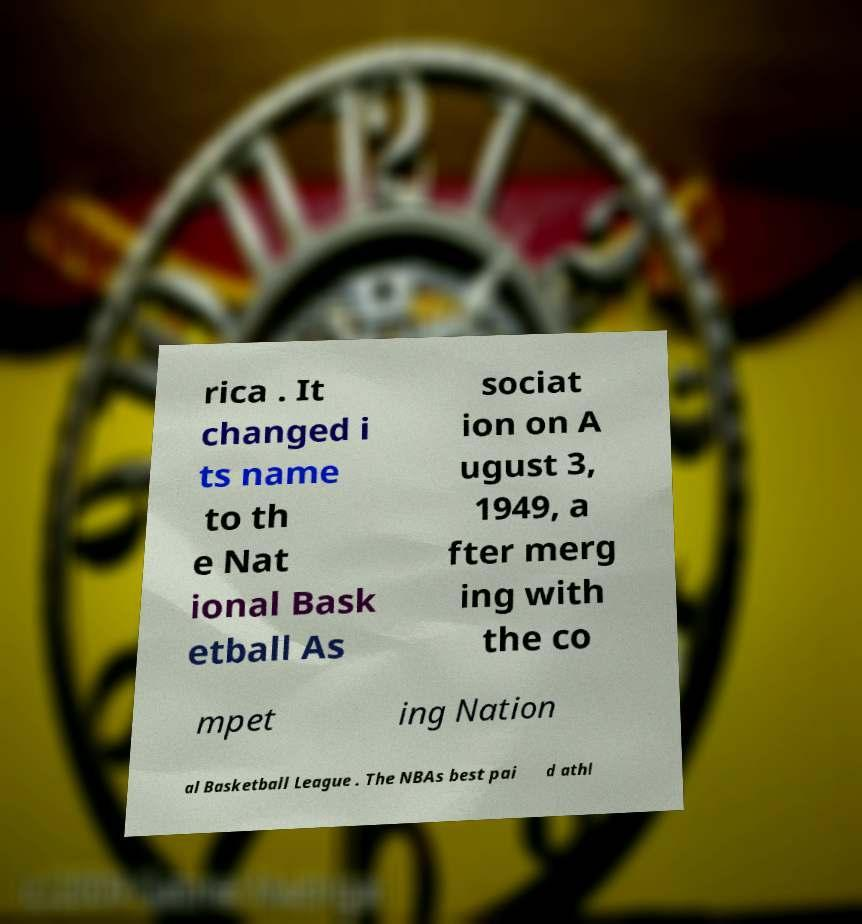Can you accurately transcribe the text from the provided image for me? rica . It changed i ts name to th e Nat ional Bask etball As sociat ion on A ugust 3, 1949, a fter merg ing with the co mpet ing Nation al Basketball League . The NBAs best pai d athl 